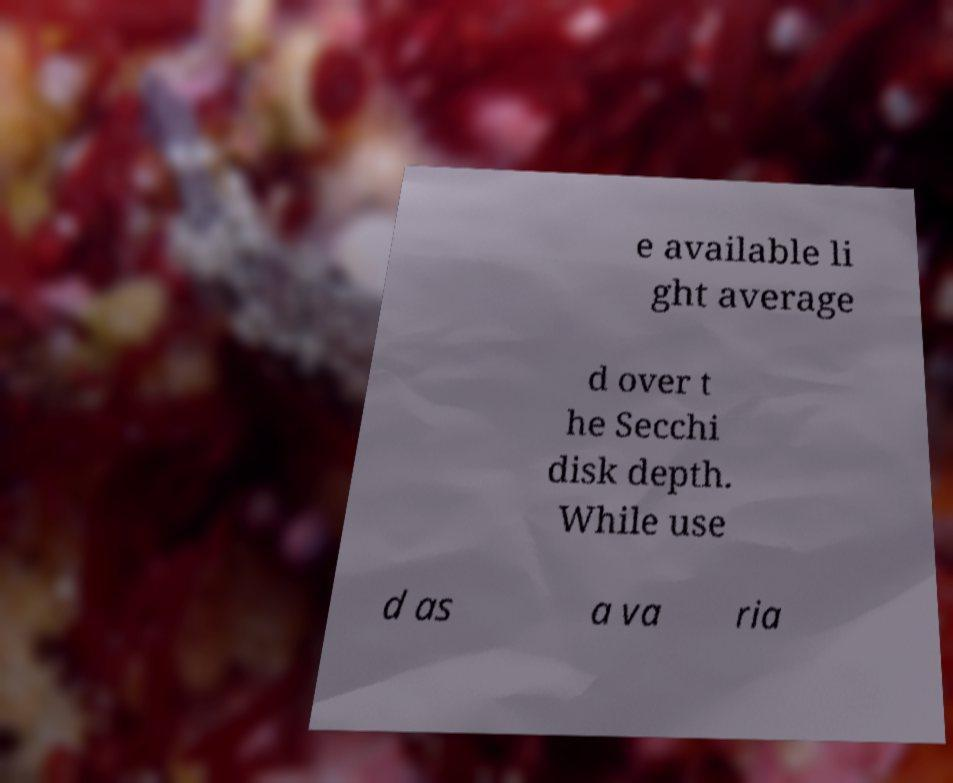Please identify and transcribe the text found in this image. e available li ght average d over t he Secchi disk depth. While use d as a va ria 